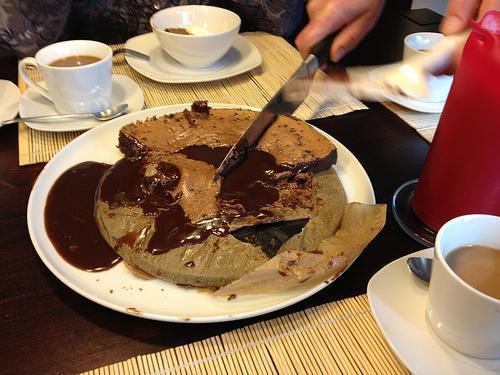How many coffee mugs are there?
Give a very brief answer. 4. 